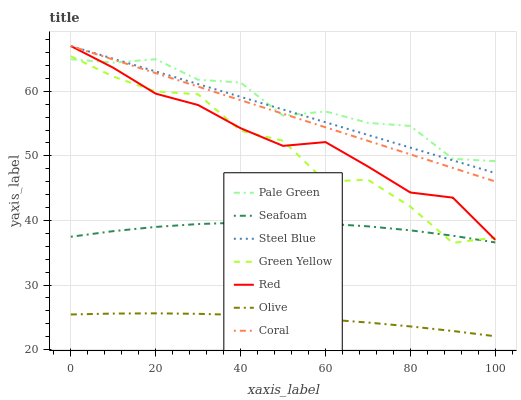Does Olive have the minimum area under the curve?
Answer yes or no. Yes. Does Pale Green have the maximum area under the curve?
Answer yes or no. Yes. Does Seafoam have the minimum area under the curve?
Answer yes or no. No. Does Seafoam have the maximum area under the curve?
Answer yes or no. No. Is Steel Blue the smoothest?
Answer yes or no. Yes. Is Green Yellow the roughest?
Answer yes or no. Yes. Is Seafoam the smoothest?
Answer yes or no. No. Is Seafoam the roughest?
Answer yes or no. No. Does Seafoam have the lowest value?
Answer yes or no. No. Does Red have the highest value?
Answer yes or no. Yes. Does Seafoam have the highest value?
Answer yes or no. No. Is Green Yellow less than Coral?
Answer yes or no. Yes. Is Green Yellow greater than Olive?
Answer yes or no. Yes. Does Green Yellow intersect Coral?
Answer yes or no. No. 